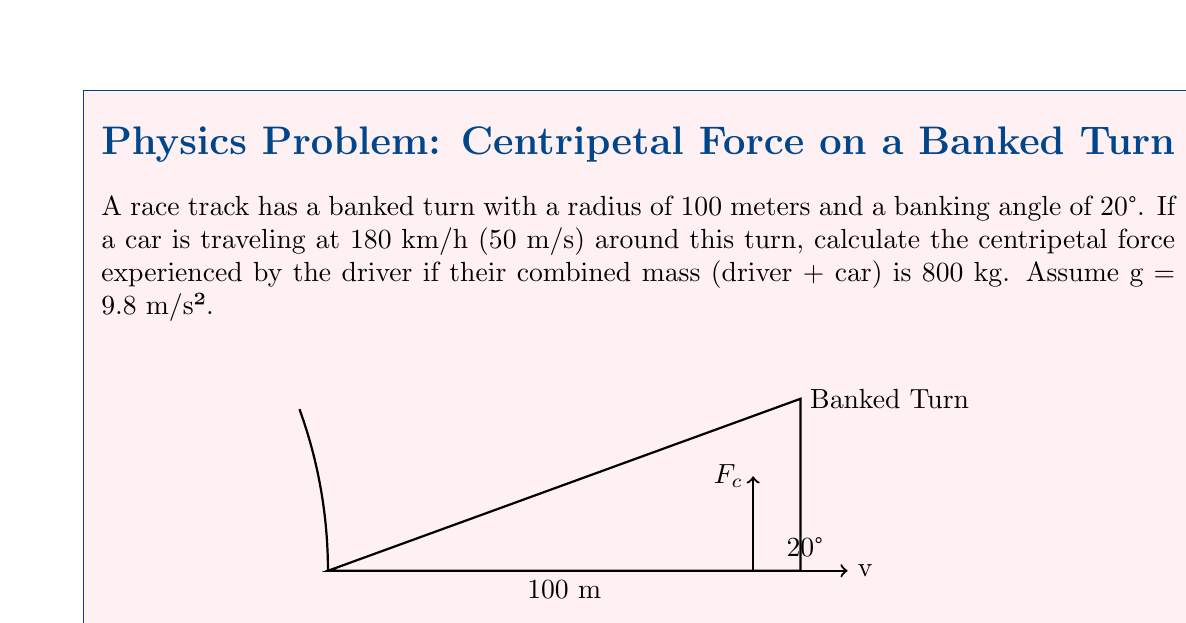Could you help me with this problem? Let's approach this step-by-step:

1) First, we need to recall the formula for centripetal force:

   $$F_c = \frac{mv^2}{r}$$

   where $F_c$ is the centripetal force, $m$ is the mass, $v$ is the velocity, and $r$ is the radius of the turn.

2) We're given:
   - $m = 800$ kg
   - $v = 50$ m/s
   - $r = 100$ m

3) Let's substitute these values into our formula:

   $$F_c = \frac{800 \cdot (50)^2}{100}$$

4) Simplify:
   
   $$F_c = \frac{800 \cdot 2500}{100} = 20000 \text{ N}$$

5) However, this is not the full story. On a banked turn, part of the normal force from the road provides the centripetal force. We need to find the component of the normal force that acts towards the center of the turn.

6) The component of the normal force acting towards the center is:

   $$F_c = N \sin \theta$$

   where $N$ is the normal force and $\theta$ is the banking angle.

7) We can find $N$ by considering the forces perpendicular to the banked surface:

   $$N \cos \theta = mg$$

   $$N = \frac{mg}{\cos \theta} = \frac{800 \cdot 9.8}{\cos 20°} = 8324.4 \text{ N}$$

8) Now we can find the actual centripetal force:

   $$F_c = N \sin \theta = 8324.4 \cdot \sin 20° = 2846.6 \text{ N}$$

This is the centripetal force experienced by the driver during the banked turn.
Answer: $2846.6 \text{ N}$ 